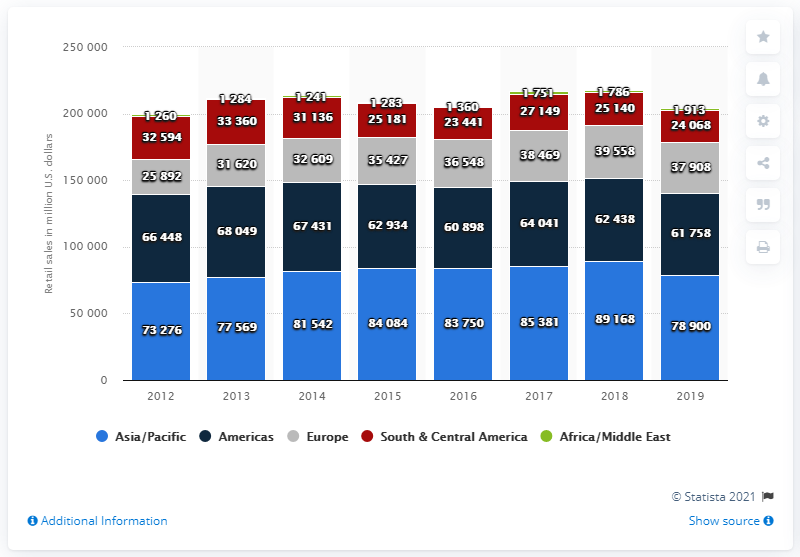Identify some key points in this picture. In 2019, the Americas generated $61,758 million through direct selling retail sales. 